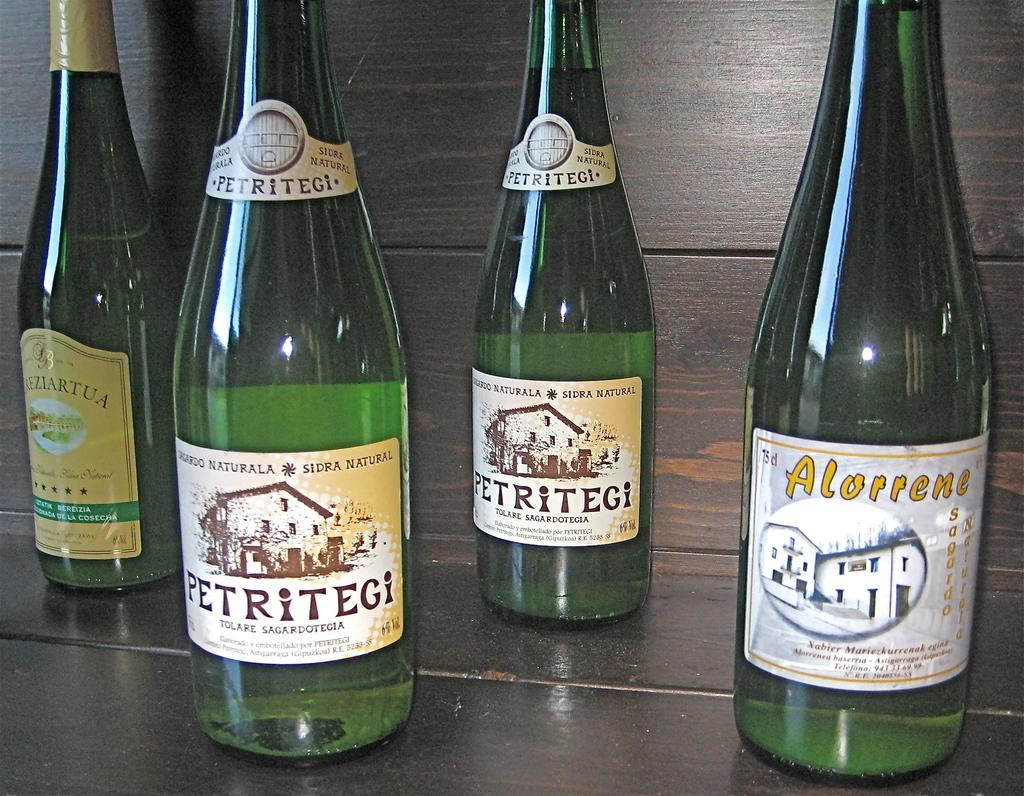<image>
Give a short and clear explanation of the subsequent image. Out of 4 bottles of wine, two are Petritegi. 